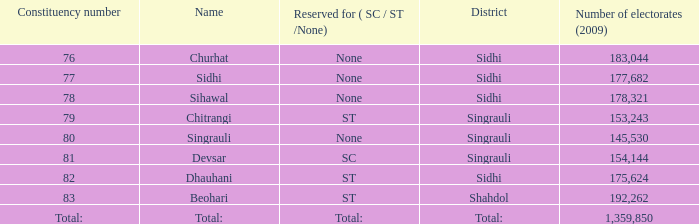What is Beohari's reserved for (SC/ST/None)? ST. 